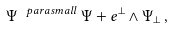Convert formula to latex. <formula><loc_0><loc_0><loc_500><loc_500>\Psi ^ { \ p a r a s m a l l } \, \Psi + e ^ { \bot } \wedge \Psi _ { \bot } { \, } ,</formula> 